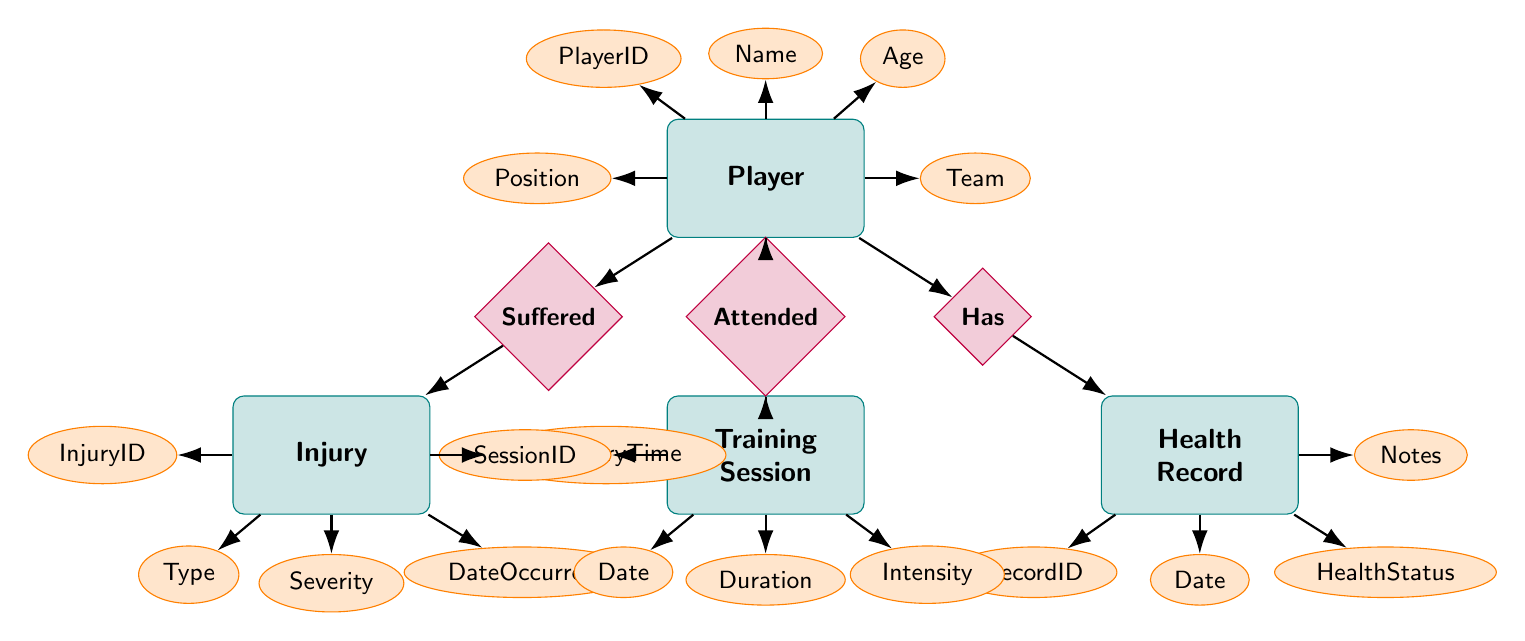What are the attributes of a Player? The Player entity includes attributes such as PlayerID, Name, Age, Position, and Team. These attributes are depicted next to the Player entity in the diagram.
Answer: PlayerID, Name, Age, Position, Team How many entities are present in the diagram? The diagram has four main entities: Player, HealthRecord, Injury, and TrainingSession. Counting these gives us a total of four entities.
Answer: 4 What relationship connects Player to HealthRecord? The relationship that connects Player to HealthRecord is labeled as "Has." This indicates that a Player can have one or more HealthRecords.
Answer: Has What type of injury can a Player suffer? The Injury entity shows the attribute Type, indicating that there can be various types of injuries that a Player can suffer. However, the specific types are not detailed in the diagram; only that the attribute exists.
Answer: Type Which entity is related to TrainingSession through a relationship? The Player entity is related to the TrainingSession entity through the relationship labeled "Attended." This signifies that players attend training sessions.
Answer: Player What is the severity of an injury associated with a Player? The Injury entity includes the attribute Severity. Since there's no specific mention of severity levels in the diagram, we can only identify that it exists as an attribute and must contain a value.
Answer: Severity Which attribute provides the date of an Injury? The date when an injury occurred is specified by the attribute named DateOccurred within the Injury entity, denoting when the injury took place.
Answer: DateOccurred How many relationships are there between Player and TrainingSession? There is one relationship depicted, labeled "Attended," showing that a Player can attend multiple TrainingSessions, but it measures as a single defined relationship.
Answer: 1 What are the attributes associated with TrainingSession? The TrainingSession entity is defined by its attributes, which are SessionID, Date, Duration, and Intensity. These attributes describe various aspects of training sessions.
Answer: SessionID, Date, Duration, Intensity What does the relationship "Suffered" signify in the diagram? The relationship "Suffered" indicates the connection between Player and Injury, demonstrating that a Player can experience injuries. It represents how the instances of a player relate to their injuries.
Answer: Suffered 